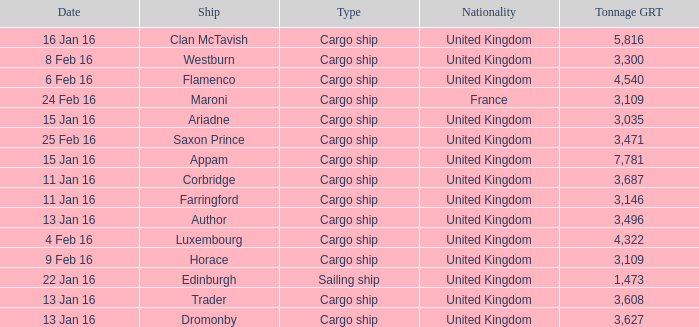What is the nationality of the ship appam? United Kingdom. 